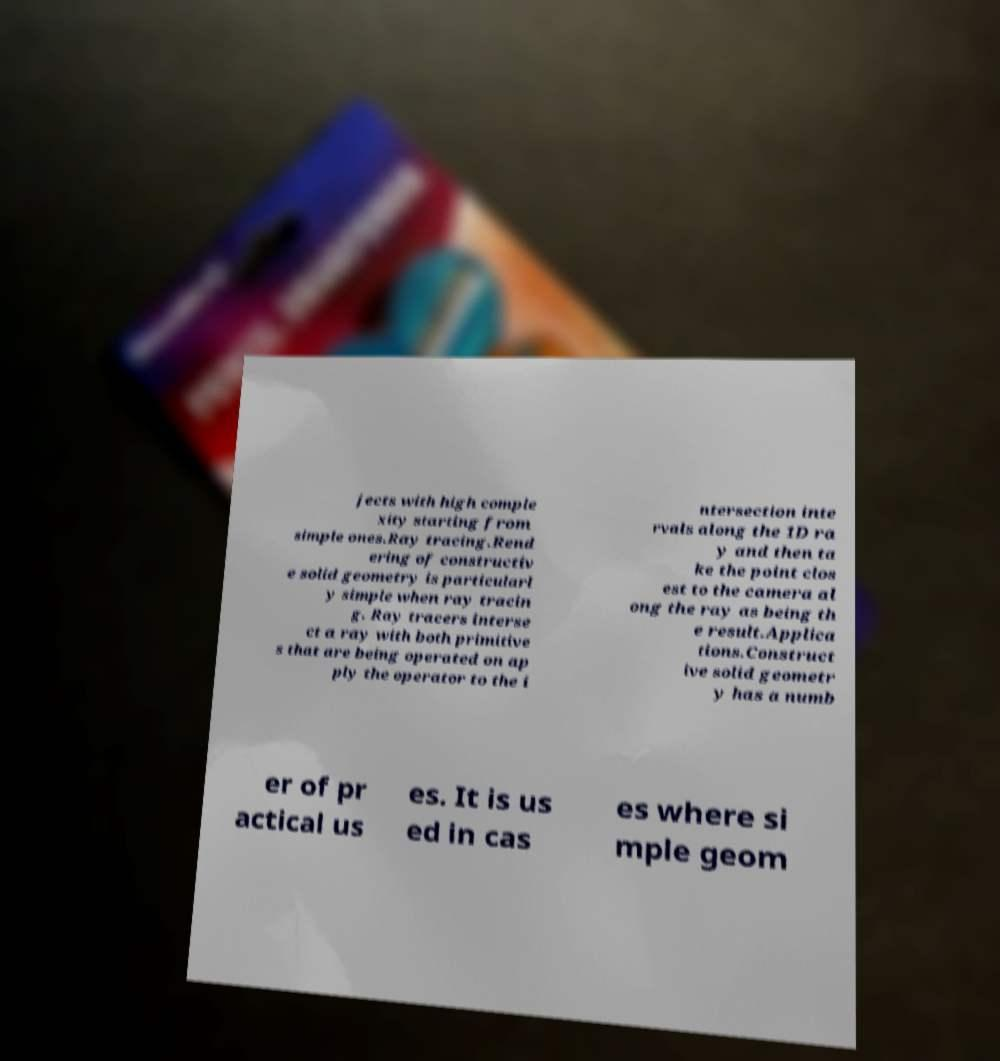Can you accurately transcribe the text from the provided image for me? jects with high comple xity starting from simple ones.Ray tracing.Rend ering of constructiv e solid geometry is particularl y simple when ray tracin g. Ray tracers interse ct a ray with both primitive s that are being operated on ap ply the operator to the i ntersection inte rvals along the 1D ra y and then ta ke the point clos est to the camera al ong the ray as being th e result.Applica tions.Construct ive solid geometr y has a numb er of pr actical us es. It is us ed in cas es where si mple geom 